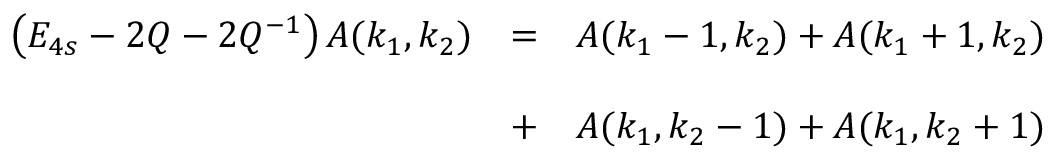Convert formula to latex. <formula><loc_0><loc_0><loc_500><loc_500>\begin{array} { l l l } { { \left ( E _ { 4 s } - 2 Q - 2 Q ^ { - 1 } \right ) A ( k _ { 1 } , k _ { 2 } ) } } & { = } & { { A ( k _ { 1 } - 1 , k _ { 2 } ) + A ( k _ { 1 } + 1 , k _ { 2 } ) } } & { + } & { { A ( k _ { 1 } , k _ { 2 } - 1 ) + A ( k _ { 1 } , k _ { 2 } + 1 ) } } \end{array}</formula> 